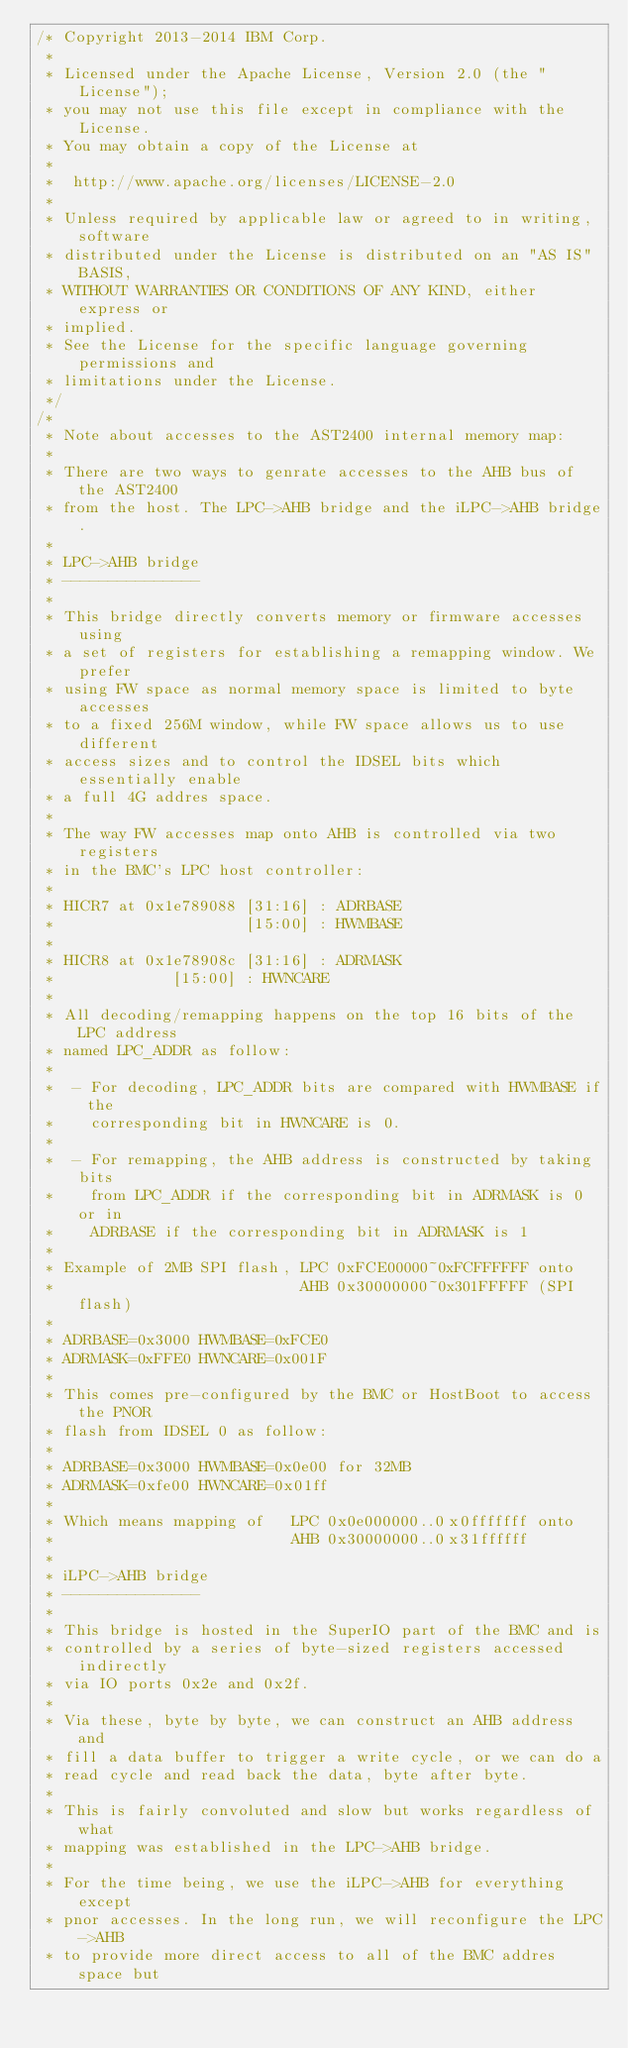<code> <loc_0><loc_0><loc_500><loc_500><_C_>/* Copyright 2013-2014 IBM Corp.
 *
 * Licensed under the Apache License, Version 2.0 (the "License");
 * you may not use this file except in compliance with the License.
 * You may obtain a copy of the License at
 *
 * 	http://www.apache.org/licenses/LICENSE-2.0
 *
 * Unless required by applicable law or agreed to in writing, software
 * distributed under the License is distributed on an "AS IS" BASIS,
 * WITHOUT WARRANTIES OR CONDITIONS OF ANY KIND, either express or
 * implied.
 * See the License for the specific language governing permissions and
 * limitations under the License.
 */
/*
 * Note about accesses to the AST2400 internal memory map:
 *
 * There are two ways to genrate accesses to the AHB bus of the AST2400
 * from the host. The LPC->AHB bridge and the iLPC->AHB bridge.
 *
 * LPC->AHB bridge
 * ---------------
 *
 * This bridge directly converts memory or firmware accesses using
 * a set of registers for establishing a remapping window. We prefer
 * using FW space as normal memory space is limited to byte accesses
 * to a fixed 256M window, while FW space allows us to use different
 * access sizes and to control the IDSEL bits which essentially enable
 * a full 4G addres space.
 *
 * The way FW accesses map onto AHB is controlled via two registers
 * in the BMC's LPC host controller:
 *
 * HICR7 at 0x1e789088 [31:16] : ADRBASE
 *                     [15:00] : HWMBASE
 *
 * HICR8 at 0x1e78908c [31:16] : ADRMASK
 *		       [15:00] : HWNCARE
 *
 * All decoding/remapping happens on the top 16 bits of the LPC address
 * named LPC_ADDR as follow:
 *
 *  - For decoding, LPC_ADDR bits are compared with HWMBASE if the
 *    corresponding bit in HWNCARE is 0.
 *
 *  - For remapping, the AHB address is constructed by taking bits
 *    from LPC_ADDR if the corresponding bit in ADRMASK is 0 or in
 *    ADRBASE if the corresponding bit in ADRMASK is 1
 *
 * Example of 2MB SPI flash, LPC 0xFCE00000~0xFCFFFFFF onto
 *                           AHB 0x30000000~0x301FFFFF (SPI flash)
 *
 * ADRBASE=0x3000 HWMBASE=0xFCE0
 * ADRMASK=0xFFE0 HWNCARE=0x001F
 *
 * This comes pre-configured by the BMC or HostBoot to access the PNOR
 * flash from IDSEL 0 as follow:
 *
 * ADRBASE=0x3000 HWMBASE=0x0e00 for 32MB
 * ADRMASK=0xfe00 HWNCARE=0x01ff
 *
 * Which means mapping of   LPC 0x0e000000..0x0fffffff onto
 *                          AHB 0x30000000..0x31ffffff
 *
 * iLPC->AHB bridge
 * ---------------
 *
 * This bridge is hosted in the SuperIO part of the BMC and is
 * controlled by a series of byte-sized registers accessed indirectly
 * via IO ports 0x2e and 0x2f.
 *
 * Via these, byte by byte, we can construct an AHB address and
 * fill a data buffer to trigger a write cycle, or we can do a
 * read cycle and read back the data, byte after byte.
 *
 * This is fairly convoluted and slow but works regardless of what
 * mapping was established in the LPC->AHB bridge.
 *
 * For the time being, we use the iLPC->AHB for everything except
 * pnor accesses. In the long run, we will reconfigure the LPC->AHB
 * to provide more direct access to all of the BMC addres space but</code> 